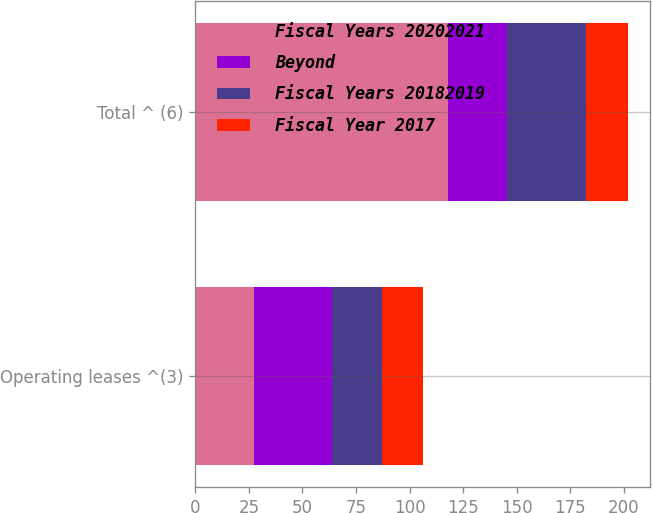<chart> <loc_0><loc_0><loc_500><loc_500><stacked_bar_chart><ecel><fcel>Operating leases ^(3)<fcel>Total ^ (6)<nl><fcel>Fiscal Years 20202021<fcel>27.5<fcel>117.9<nl><fcel>Beyond<fcel>36.1<fcel>27.5<nl><fcel>Fiscal Years 20182019<fcel>23.3<fcel>37.1<nl><fcel>Fiscal Year 2017<fcel>19.4<fcel>19.4<nl></chart> 